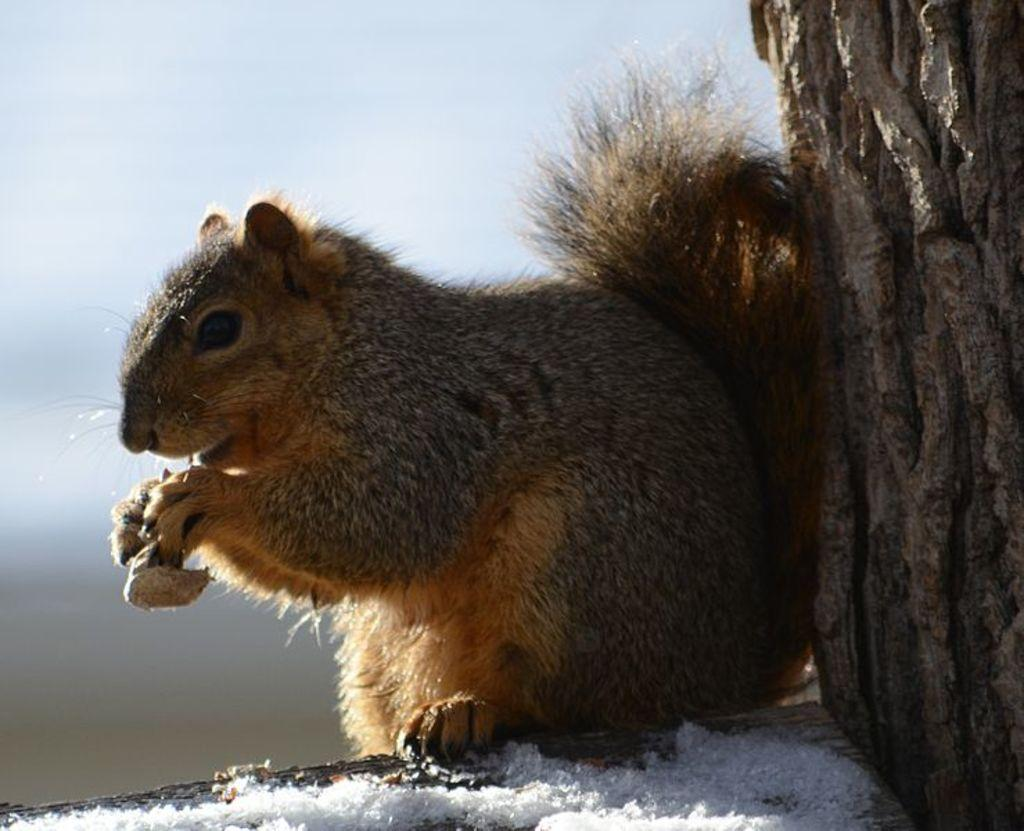What type of animal is present in the image? There is a squirrel in the image. What is the squirrel doing in the image? The squirrel is holding something in its hands. What type of vegetable is the squirrel thinking about in the image? There is no indication in the image that the squirrel is thinking about any vegetable. What type of brass object is the squirrel holding in its hands in the image? There is no brass object present in the image; the squirrel is holding something, but its composition is not mentioned. 